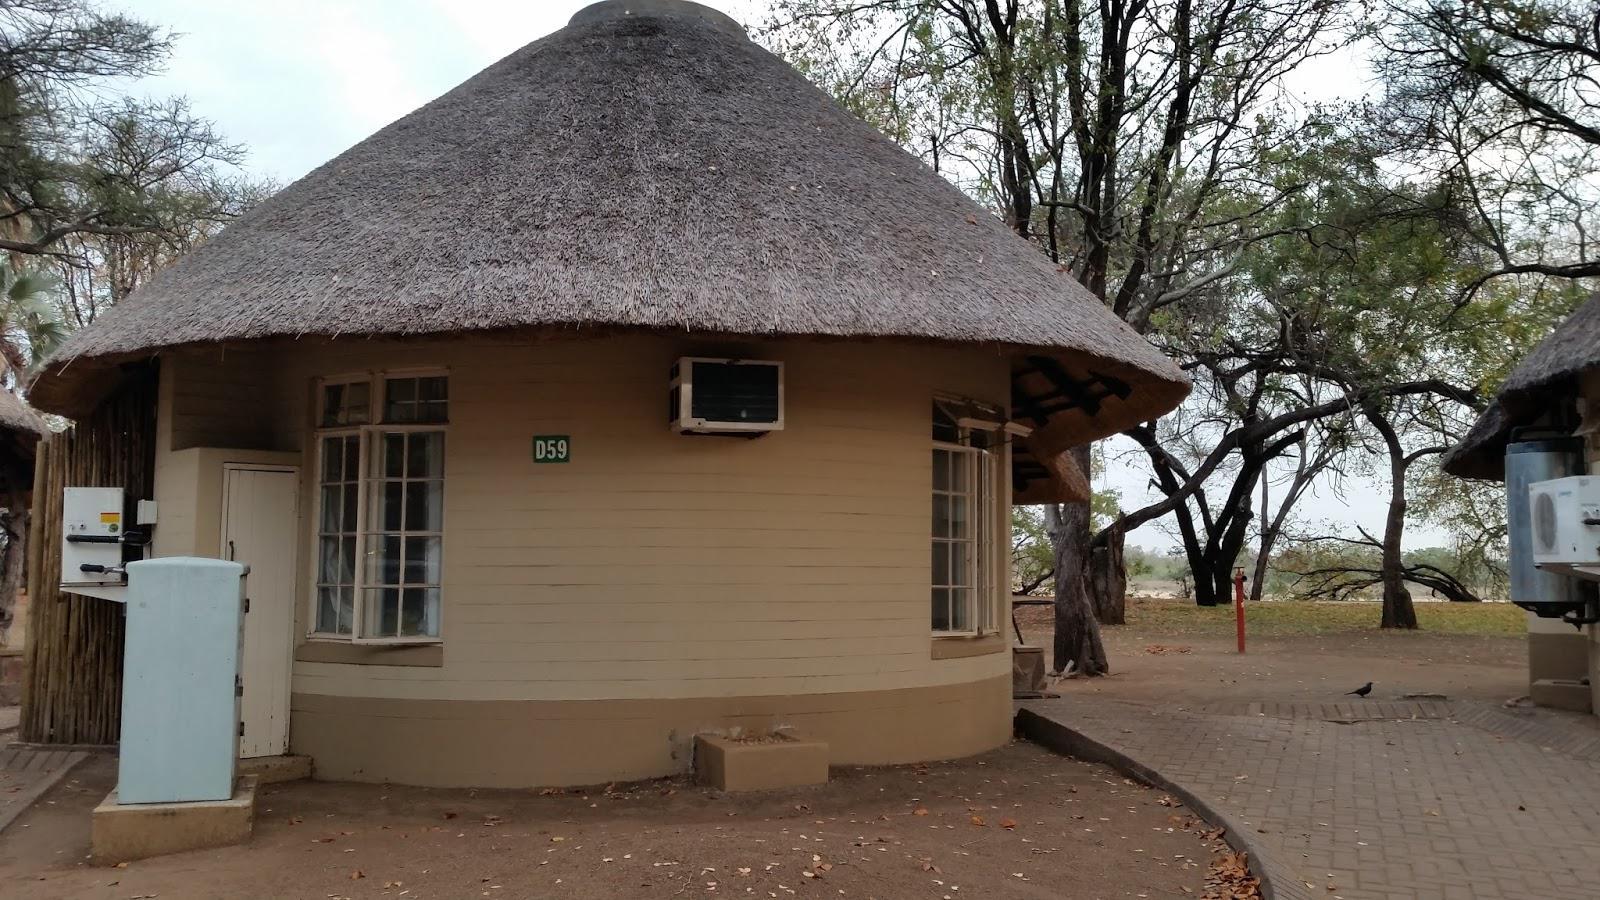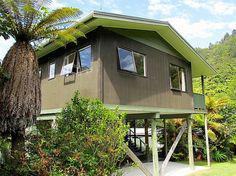The first image is the image on the left, the second image is the image on the right. For the images shown, is this caption "The right image shows a non-tiered thatch roof over an open-sided structure with square columns in the corners." true? Answer yes or no. No. The first image is the image on the left, the second image is the image on the right. For the images shown, is this caption "Both of the structures are enclosed" true? Answer yes or no. Yes. 